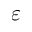<formula> <loc_0><loc_0><loc_500><loc_500>\varepsilon</formula> 